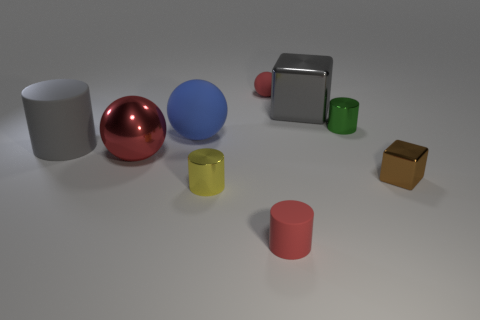What number of other things are made of the same material as the tiny block?
Provide a short and direct response. 4. There is a object that is on the right side of the small matte cylinder and behind the green cylinder; what size is it?
Provide a short and direct response. Large. What number of objects are either tiny red rubber things that are in front of the big gray rubber thing or tiny green metallic cylinders?
Give a very brief answer. 2. The big red thing that is made of the same material as the brown thing is what shape?
Your response must be concise. Sphere. The blue rubber thing has what shape?
Your answer should be very brief. Sphere. What is the color of the tiny cylinder that is both to the right of the yellow object and in front of the tiny brown metallic cube?
Make the answer very short. Red. What shape is the brown shiny object that is the same size as the green cylinder?
Offer a terse response. Cube. Is there another thing that has the same shape as the small brown shiny thing?
Provide a succinct answer. Yes. Do the tiny sphere and the tiny cylinder left of the tiny matte cylinder have the same material?
Your answer should be very brief. No. The matte cylinder to the right of the red thing that is behind the gray metallic block on the left side of the brown metal thing is what color?
Your answer should be very brief. Red. 